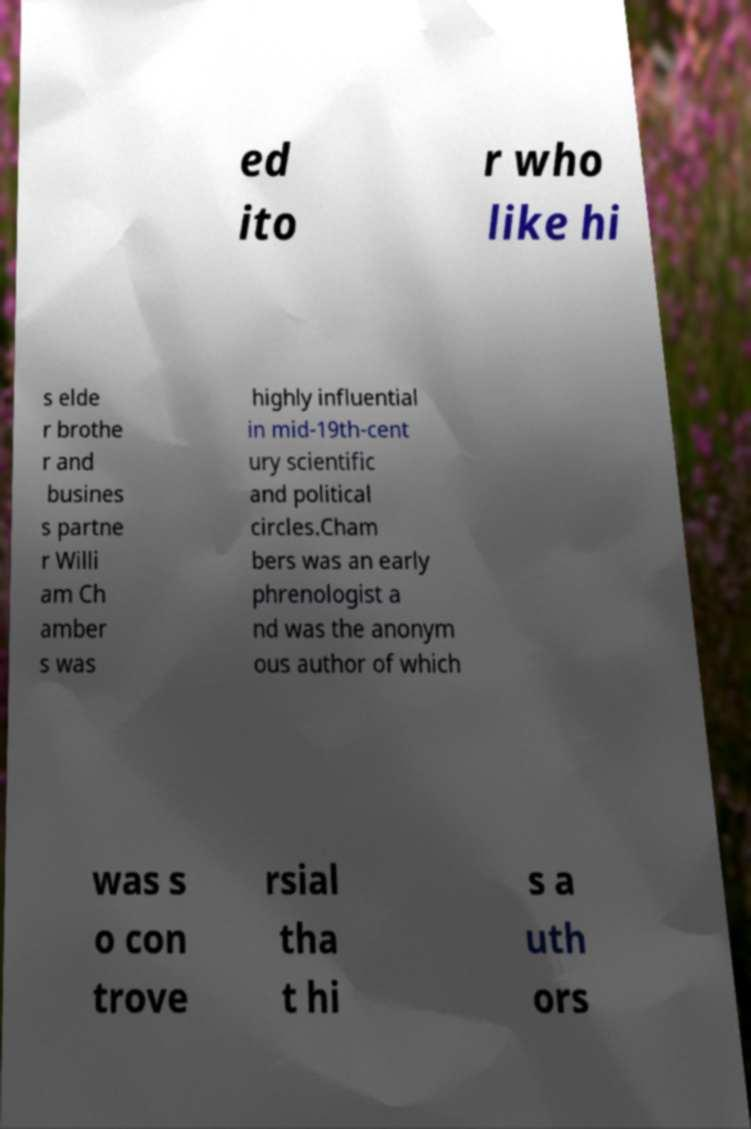For documentation purposes, I need the text within this image transcribed. Could you provide that? ed ito r who like hi s elde r brothe r and busines s partne r Willi am Ch amber s was highly influential in mid-19th-cent ury scientific and political circles.Cham bers was an early phrenologist a nd was the anonym ous author of which was s o con trove rsial tha t hi s a uth ors 